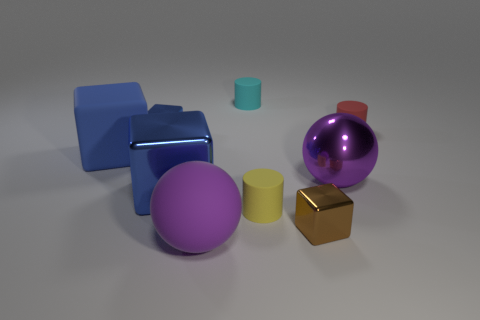The ball on the right side of the brown shiny cube that is in front of the small blue block is what color?
Your response must be concise. Purple. Do the rubber sphere and the large metal sphere have the same color?
Provide a short and direct response. Yes. What material is the blue block on the right side of the tiny metallic block behind the small yellow thing?
Provide a short and direct response. Metal. What is the material of the other big purple object that is the same shape as the purple shiny object?
Keep it short and to the point. Rubber. There is a large purple thing behind the sphere left of the small cyan thing; is there a big purple shiny ball that is in front of it?
Provide a succinct answer. No. How many other things are there of the same color as the large matte cube?
Ensure brevity in your answer.  2. What number of large things are behind the large purple matte sphere and right of the small blue shiny block?
Provide a short and direct response. 2. What shape is the cyan matte object?
Offer a terse response. Cylinder. How many other things are there of the same material as the small red cylinder?
Keep it short and to the point. 4. There is a large metallic object on the right side of the big metallic object that is in front of the ball to the right of the brown metal thing; what color is it?
Make the answer very short. Purple. 